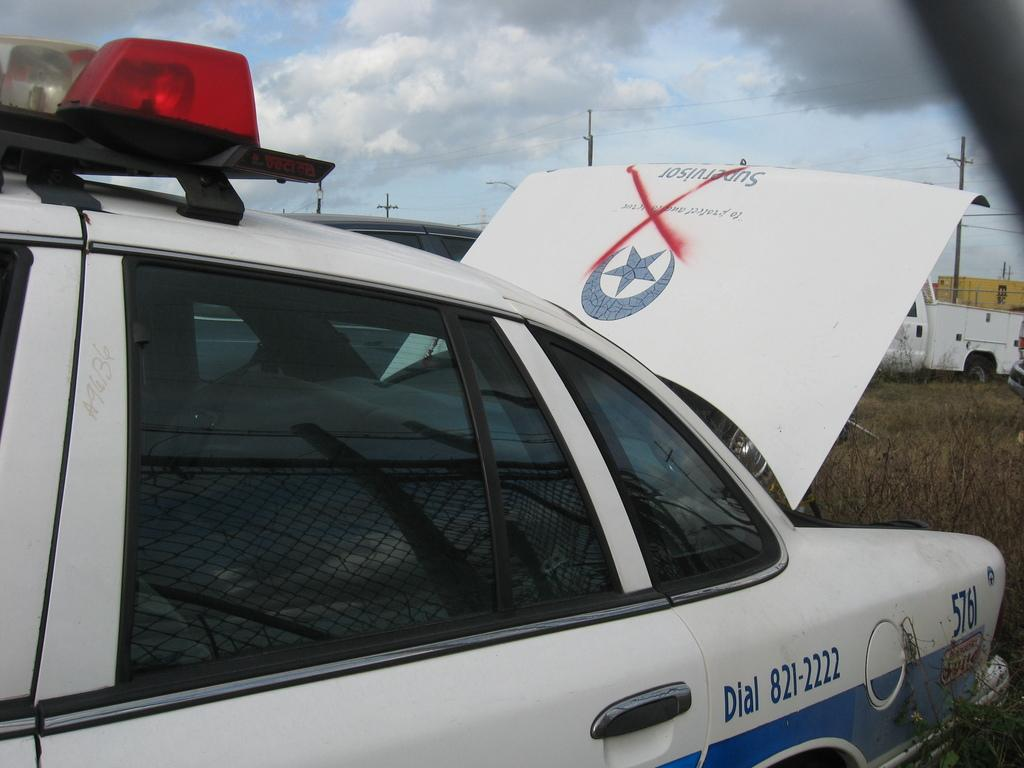<image>
Share a concise interpretation of the image provided. A cop car that says Dial 821-2222 on it. 